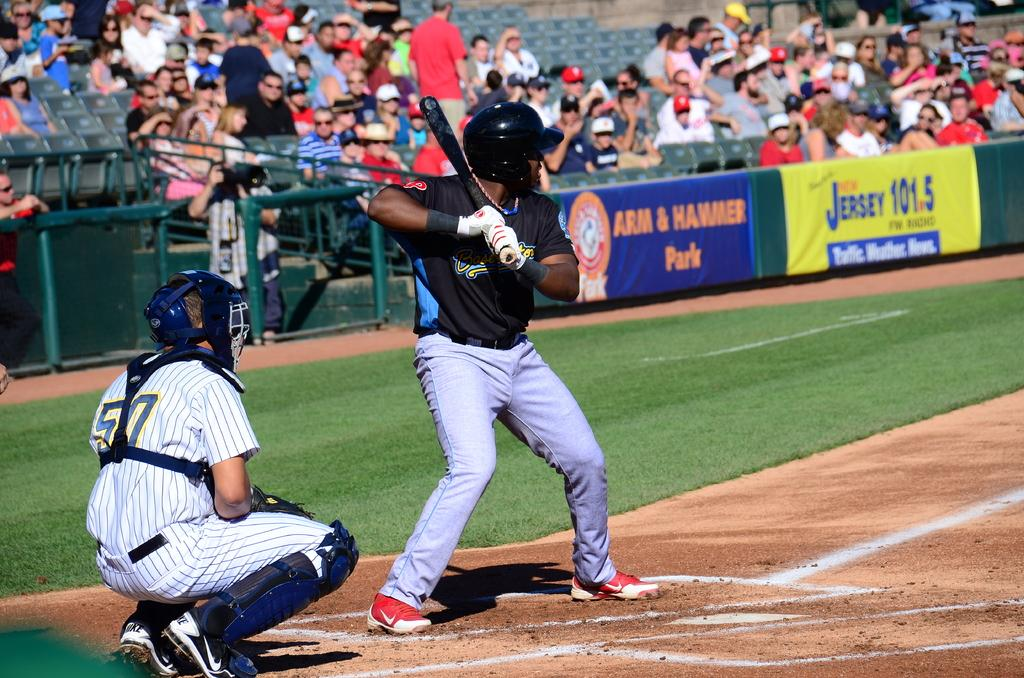<image>
Present a compact description of the photo's key features. Two baseball players playing baseball in front of a sign that reads Jersey 101.5. 